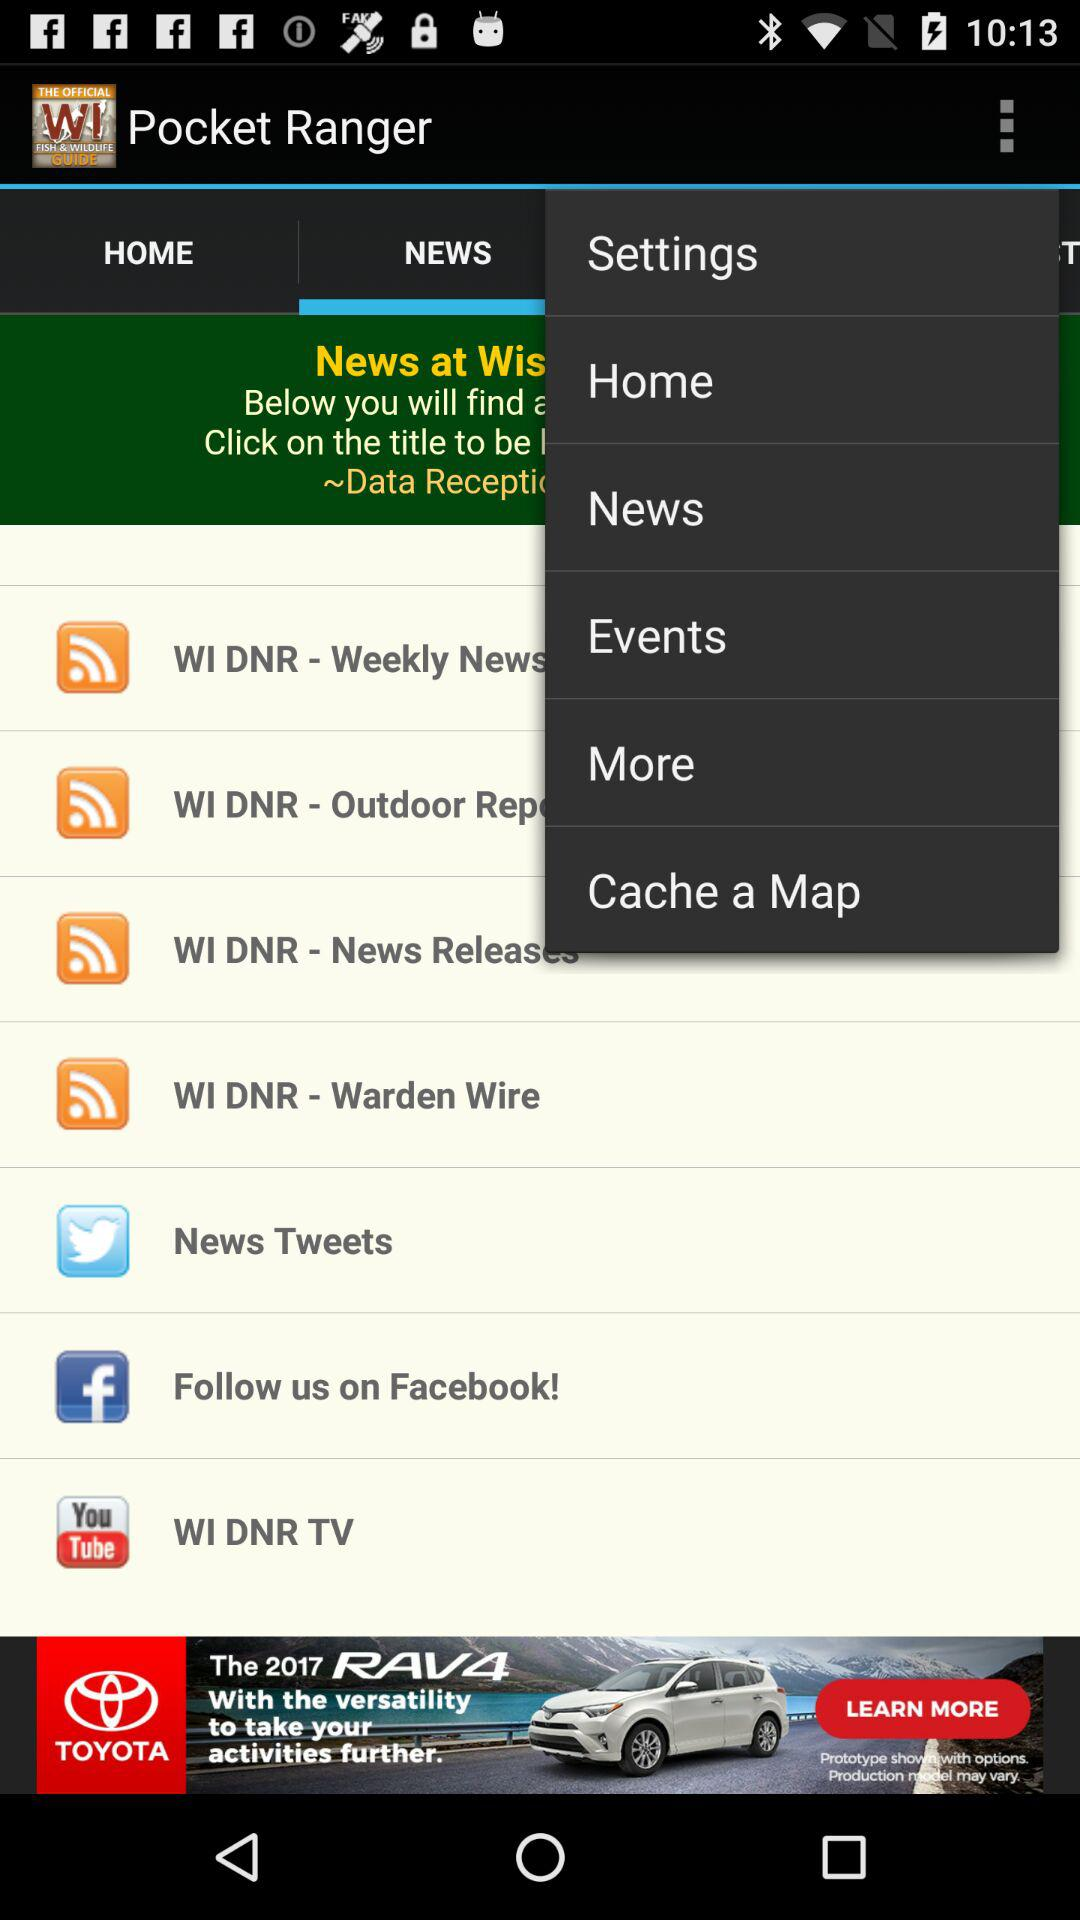Which tab am I using? You are using the "NEWS" tab. 